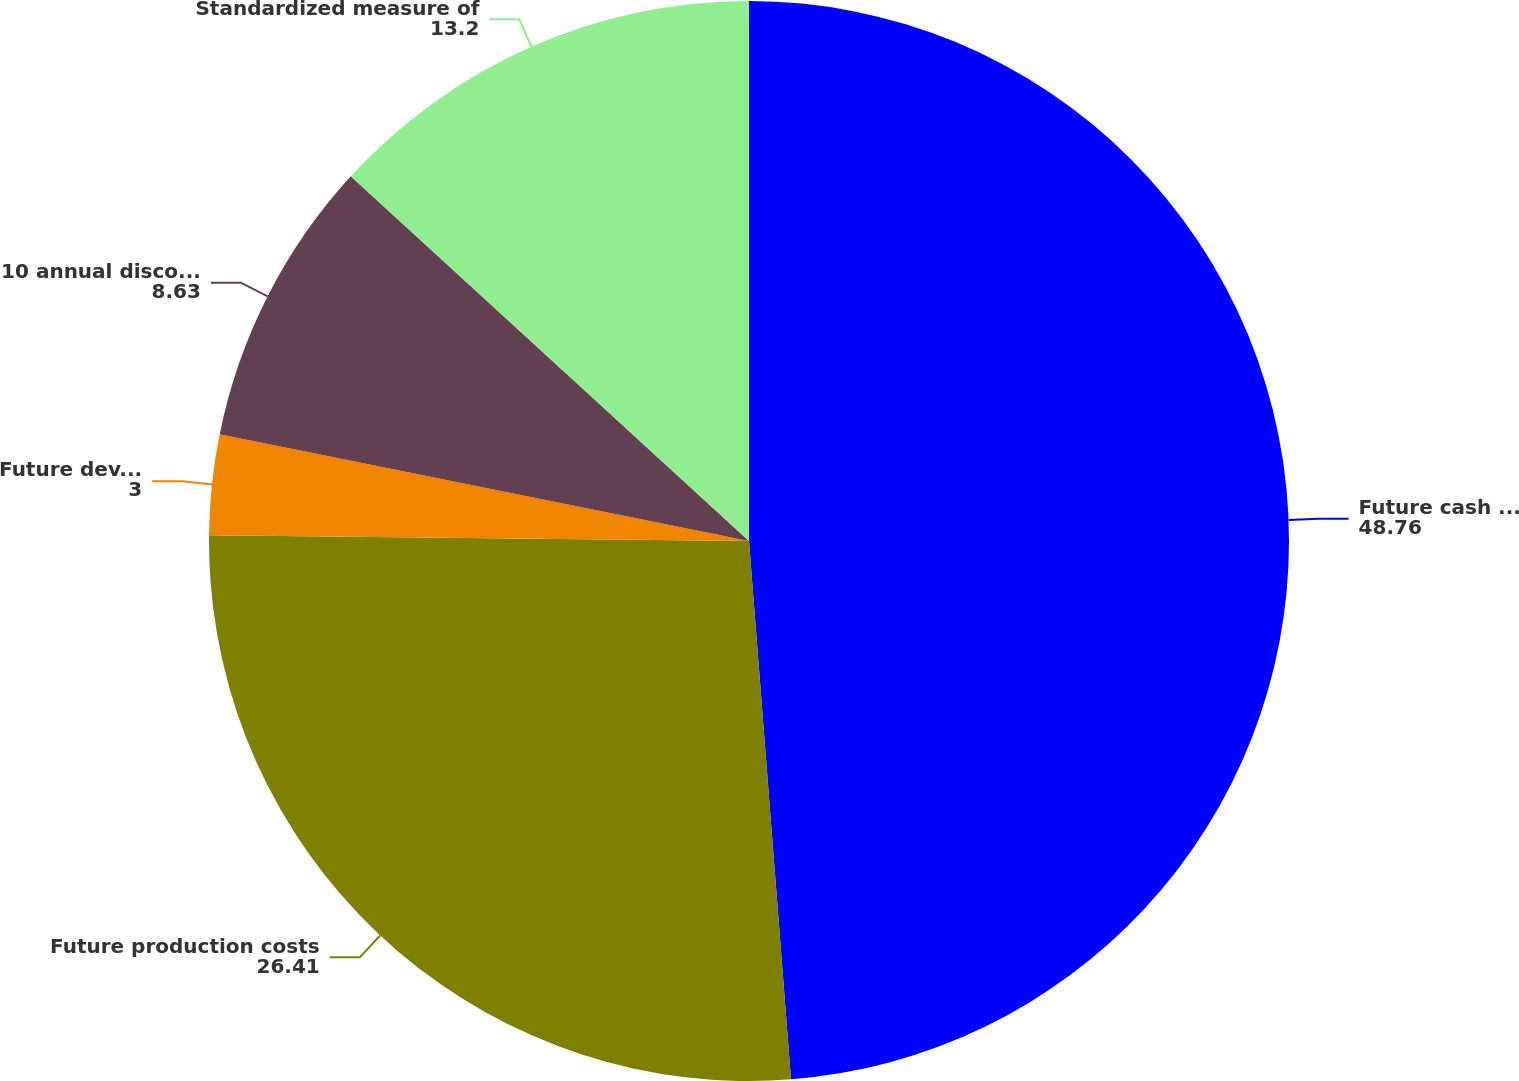Convert chart to OTSL. <chart><loc_0><loc_0><loc_500><loc_500><pie_chart><fcel>Future cash inflows<fcel>Future production costs<fcel>Future development costs (a)<fcel>10 annual discount factor<fcel>Standardized measure of<nl><fcel>48.76%<fcel>26.41%<fcel>3.0%<fcel>8.63%<fcel>13.2%<nl></chart> 